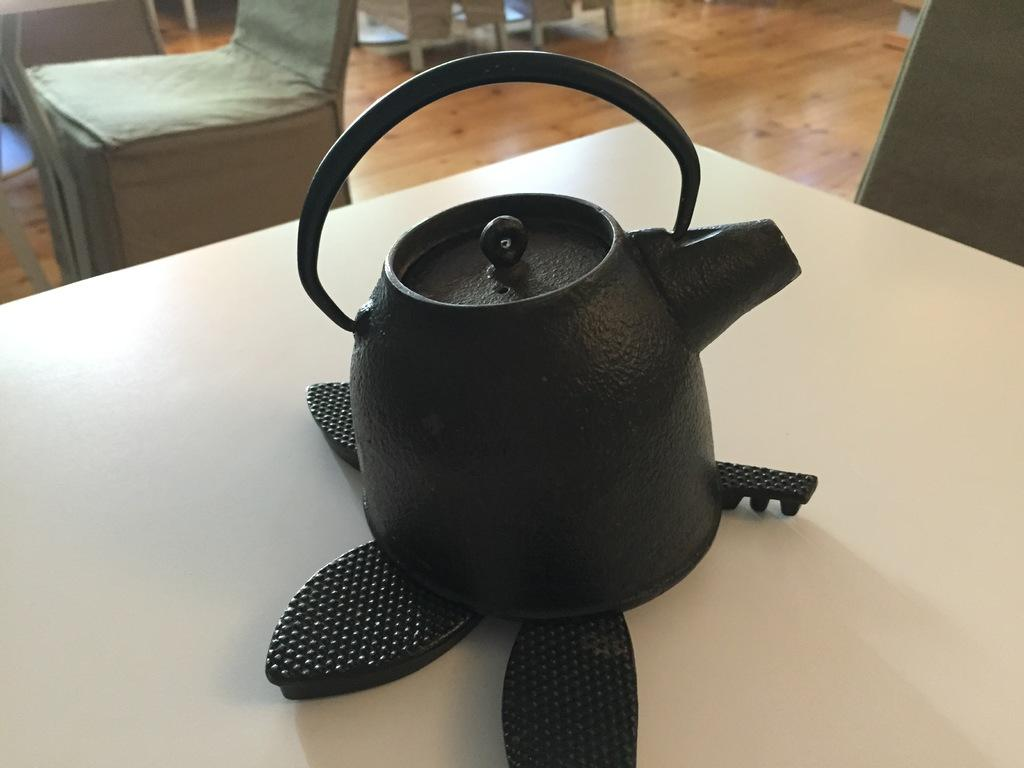What is the main object in the image? There is a tea pot in the image. Where is the tea pot located? The tea pot is on a platform. What can be seen in the background of the image? There are objects visible in the background of the image. Where are the objects in the background located? The objects are on the floor. What type of shop can be seen in the image? There is no shop present in the image; it features a tea pot on a platform with objects in the background. 